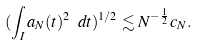<formula> <loc_0><loc_0><loc_500><loc_500>( \int _ { I } a _ { N } ( t ) ^ { 2 } \ d t ) ^ { 1 / 2 } \lesssim N ^ { - \frac { 1 } { 2 } } c _ { N } .</formula> 